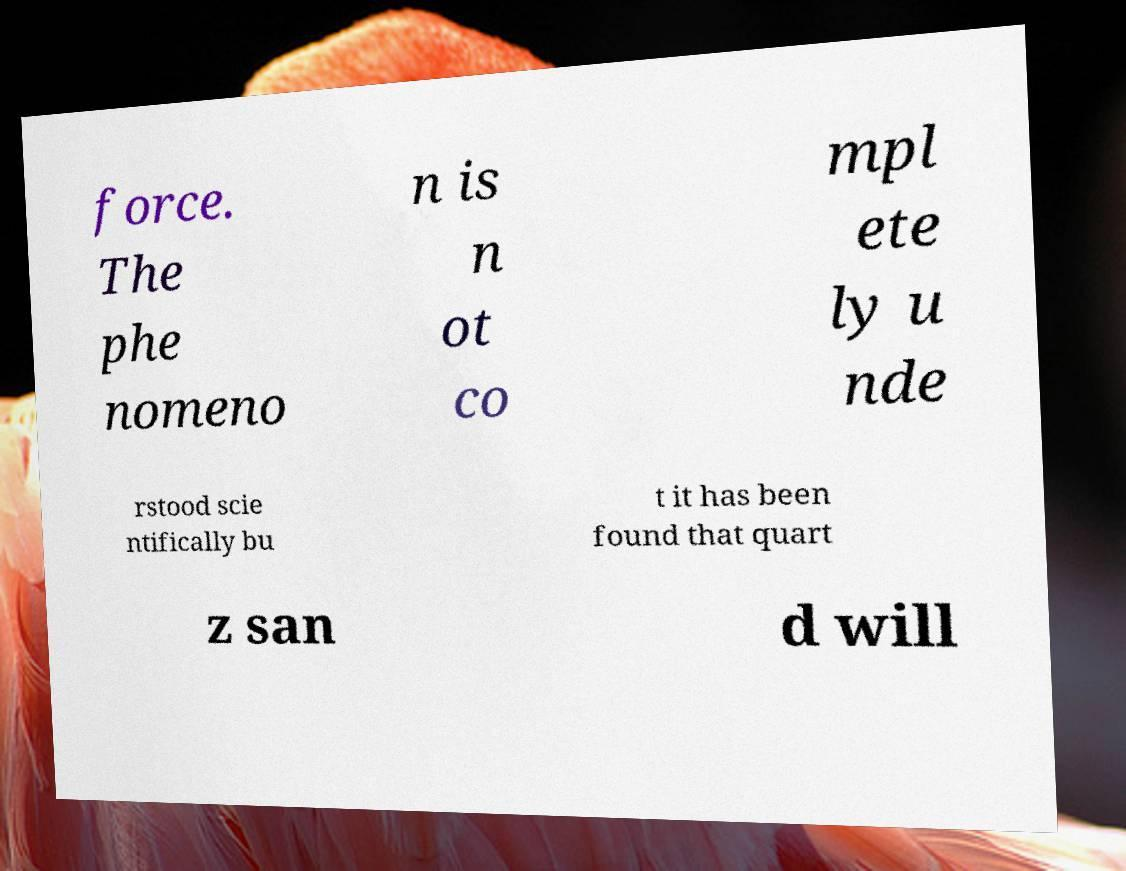Can you read and provide the text displayed in the image?This photo seems to have some interesting text. Can you extract and type it out for me? force. The phe nomeno n is n ot co mpl ete ly u nde rstood scie ntifically bu t it has been found that quart z san d will 